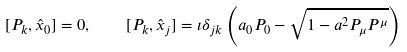<formula> <loc_0><loc_0><loc_500><loc_500>[ P _ { k } , \hat { x } _ { 0 } ] = 0 , \quad [ P _ { k } , \hat { x } _ { j } ] = \imath \delta _ { j k } \left ( a _ { 0 } P _ { 0 } - \sqrt { 1 - a ^ { 2 } P _ { \mu } P ^ { \mu } } \right )</formula> 